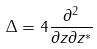<formula> <loc_0><loc_0><loc_500><loc_500>\Delta = 4 \frac { \partial ^ { 2 } } { \partial z \partial z ^ { \ast } }</formula> 